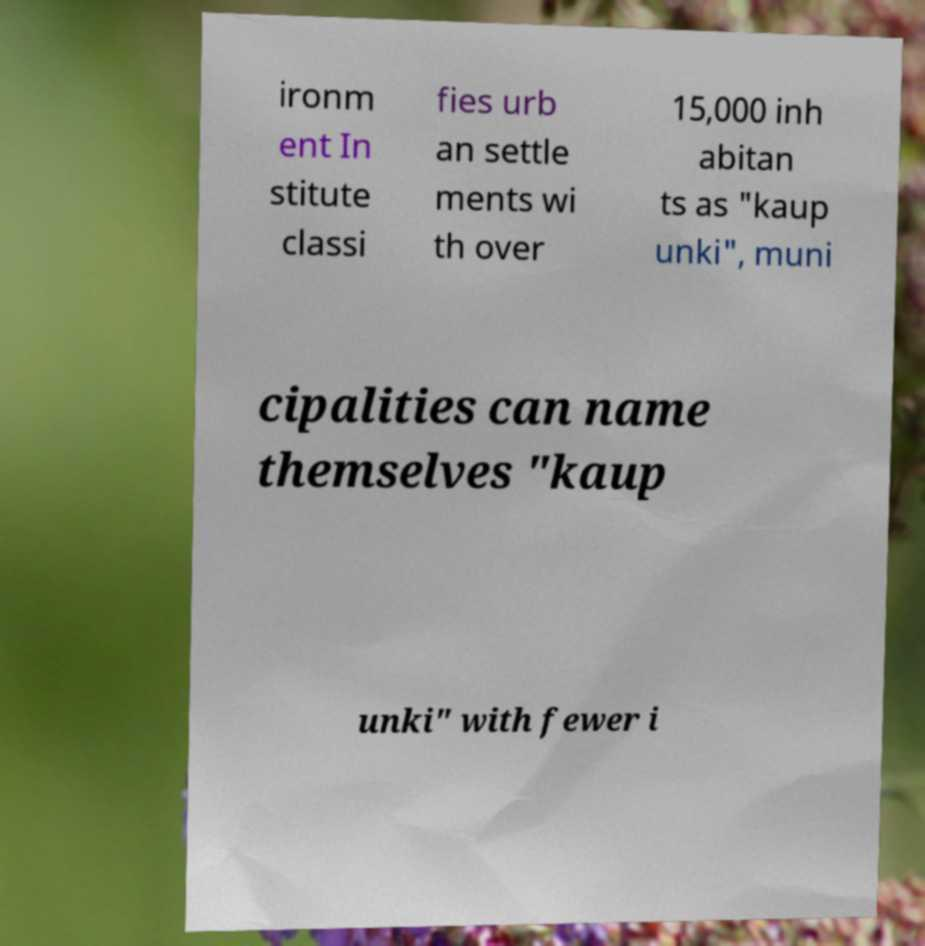Please identify and transcribe the text found in this image. ironm ent In stitute classi fies urb an settle ments wi th over 15,000 inh abitan ts as "kaup unki", muni cipalities can name themselves "kaup unki" with fewer i 